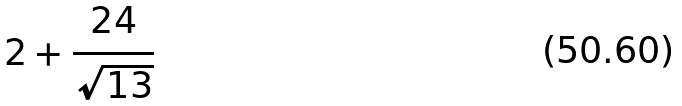Convert formula to latex. <formula><loc_0><loc_0><loc_500><loc_500>2 + \frac { 2 4 } { \sqrt { 1 3 } }</formula> 